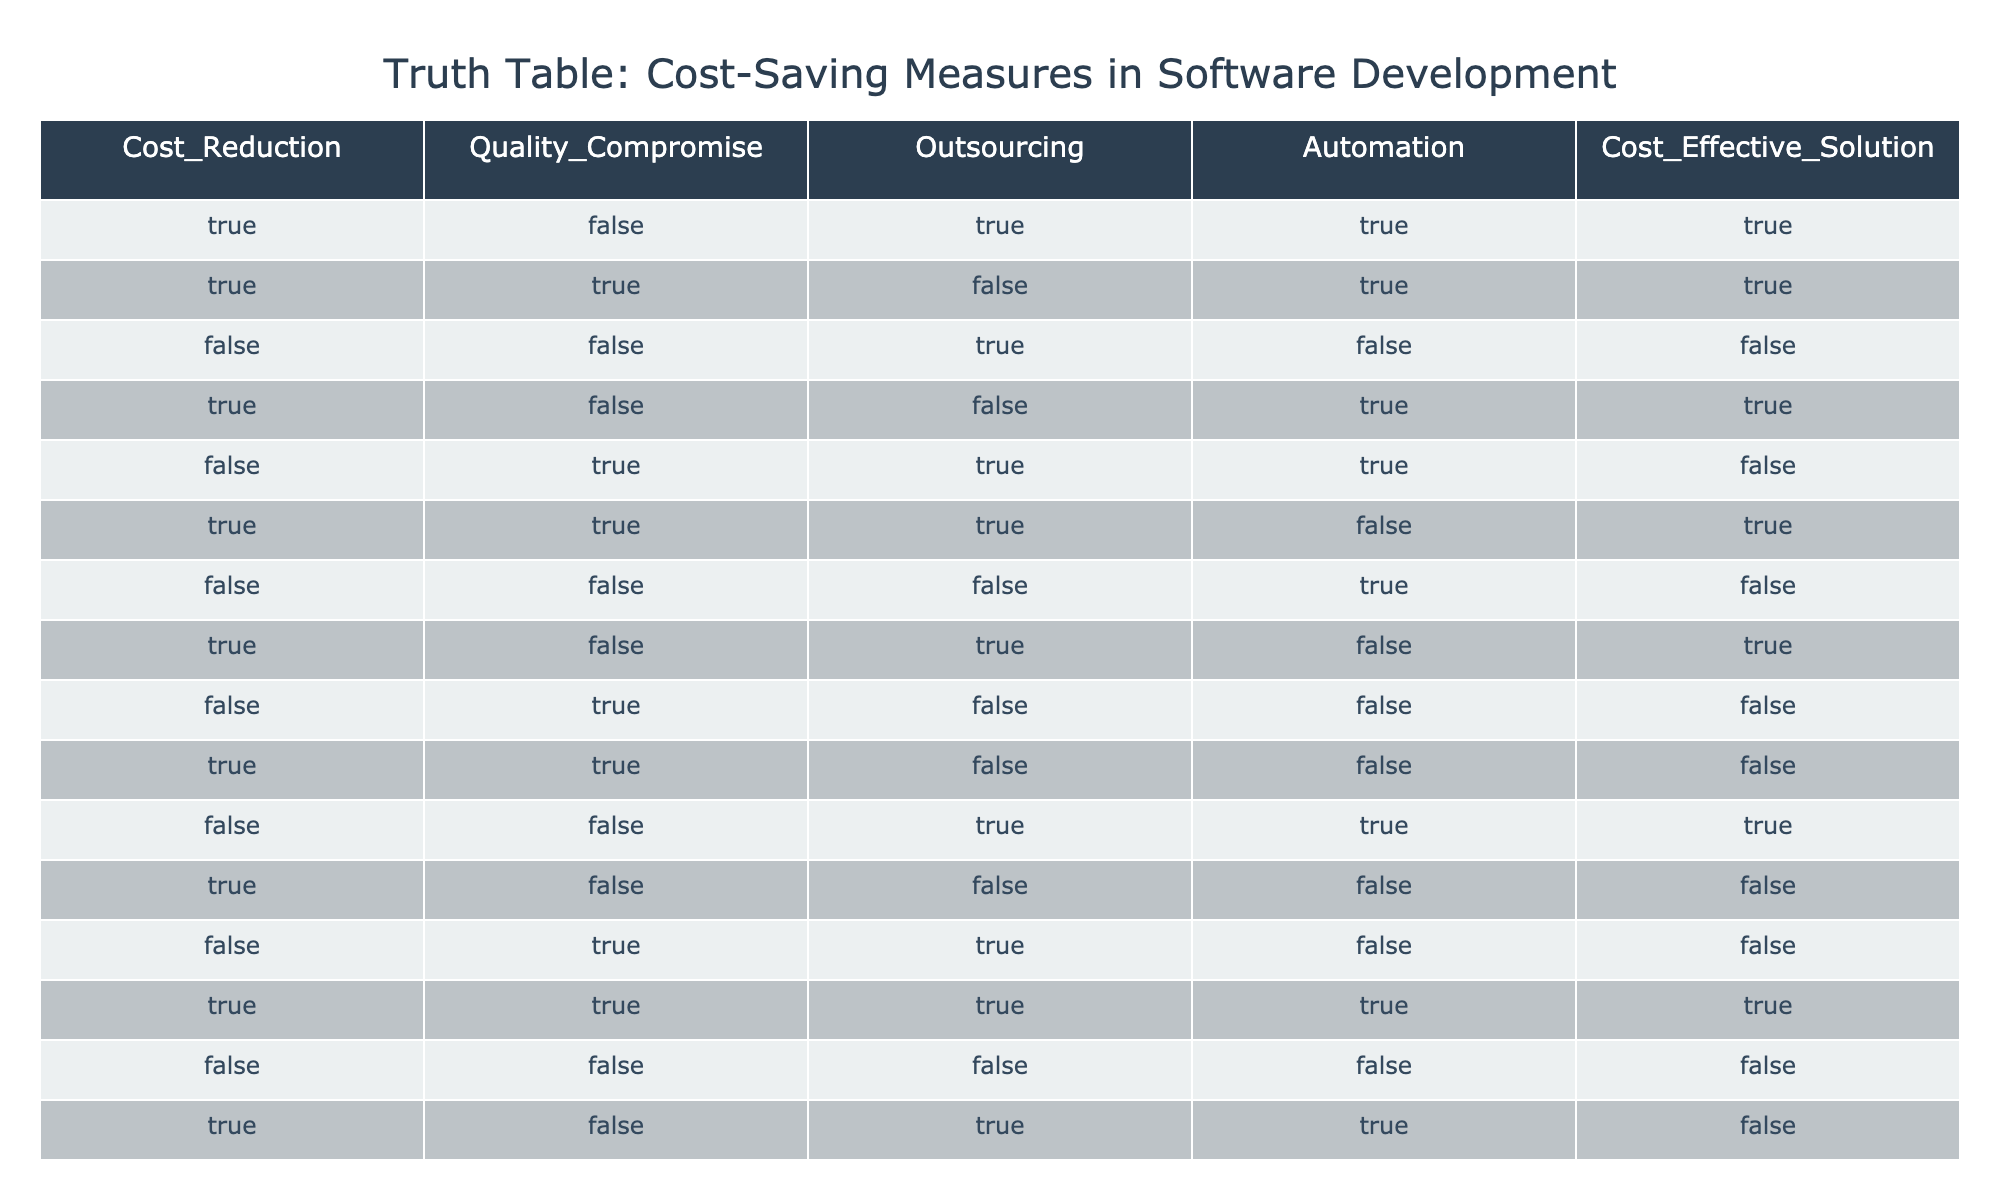What is the total number of rows where cost reduction is true? There are 8 rows in the table that have "TRUE" under the Cost_Reduction column.
Answer: 8 What combinations of quality compromise and automation yield a cost-effective solution? The combinations that yield a cost-effective solution are: (TRUE, TRUE), (FALSE, TRUE), and (FALSE, FALSE). The first and second combinations allow for cost-effectiveness while the third one depends on automation alone.
Answer: (TRUE, TRUE), (FALSE, TRUE), (FALSE, FALSE) Is it possible to achieve a cost-effective solution by compromising on quality? Yes, it is possible. Rows 2 and 5 both indicate a cost-effective solution (TRUE) despite having a quality compromise (TRUE and TRUE, respectively).
Answer: Yes Under which conditions do we see cost-effective solutions when outsourcing is true? In rows 1, 3, 5, and 11, when outsourcing is true, there are cost-effective solutions available. It requires checking the Cost_Effective_Solution column against those rows.
Answer: Rows 1, 3, 5, and 11 How many rows have a cost-effective solution while having both outsourcing and automation true? Only 1 row meets the criteria where both outsourcing and automation are true, which is row 6. The other rows with outsourcing or automation do not qualify simultaneously.
Answer: 1 What is the relationship between quality compromise and outsourcing regarding achieving cost-effective solutions? An analysis of quality compromise and outsourcing shows that there are 3 rows (1, 5, and 11) that result in a cost-effective solution without compromising quality, indicating that outsourcing can complement quality efforts but may not always guarantee cost savings.
Answer: 3 rows If we focus only on the instances where automation is true, how many of these solutions are cost-effective? There are 5 rows where automation is true (rows 1, 2, 3, 11, 14). Out of these, 3 rows (1, 2, and 11) are cost-effective. Therefore, with a focus on automation; a fair number of solutions uphold cost-effectiveness in this approach.
Answer: 3 rows What percentage of the total rows yield a cost-effective solution when cost reduction is true? Since there are 5 rows where cost reduction is true and 4 of these are cost-effective, that results in a percentage calculated by (4/5) * 100 = 80%. Hence, the majority reflects a strong emphasis on aligning cost reductions to effective solutions.
Answer: 80% 